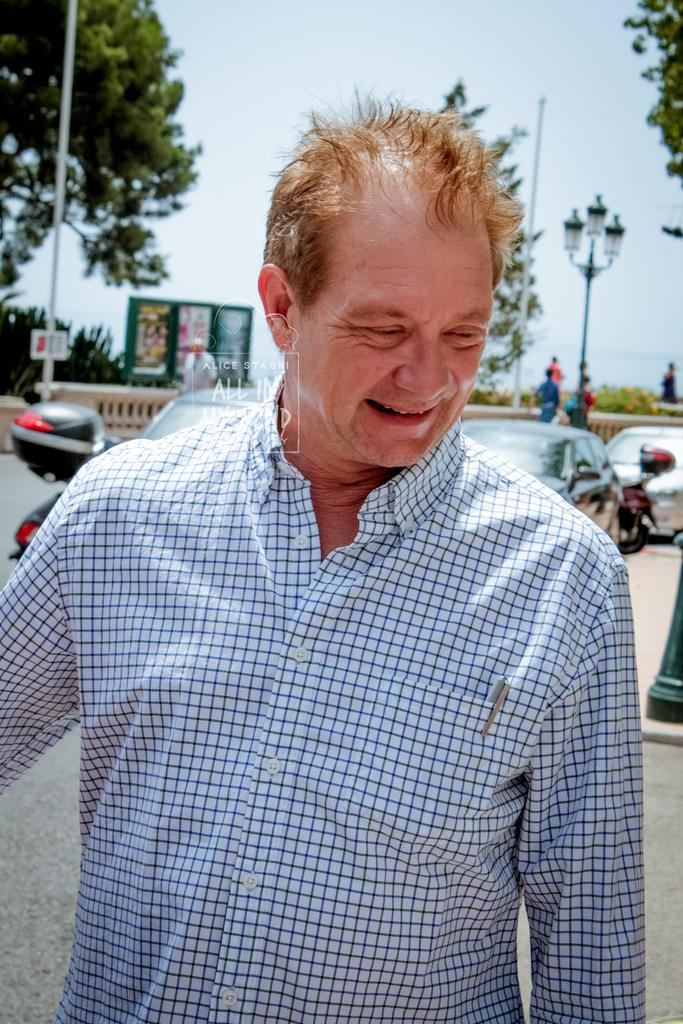What is the main subject of the image? There is a man standing on a road in the image. What can be seen in the background of the image? There are vehicles, people, light poles, trees, and the sky visible in the background of the image. Can you describe the condition of the image? The image is blurred. Is there any additional element present in the image? Yes, there is a watermark in the middle of the image. What type of turkey can be seen on top of the light pole in the image? There is no turkey present in the image, and no turkey is on top of the light pole. What type of coil is visible in the image? There is no coil visible in the image. 